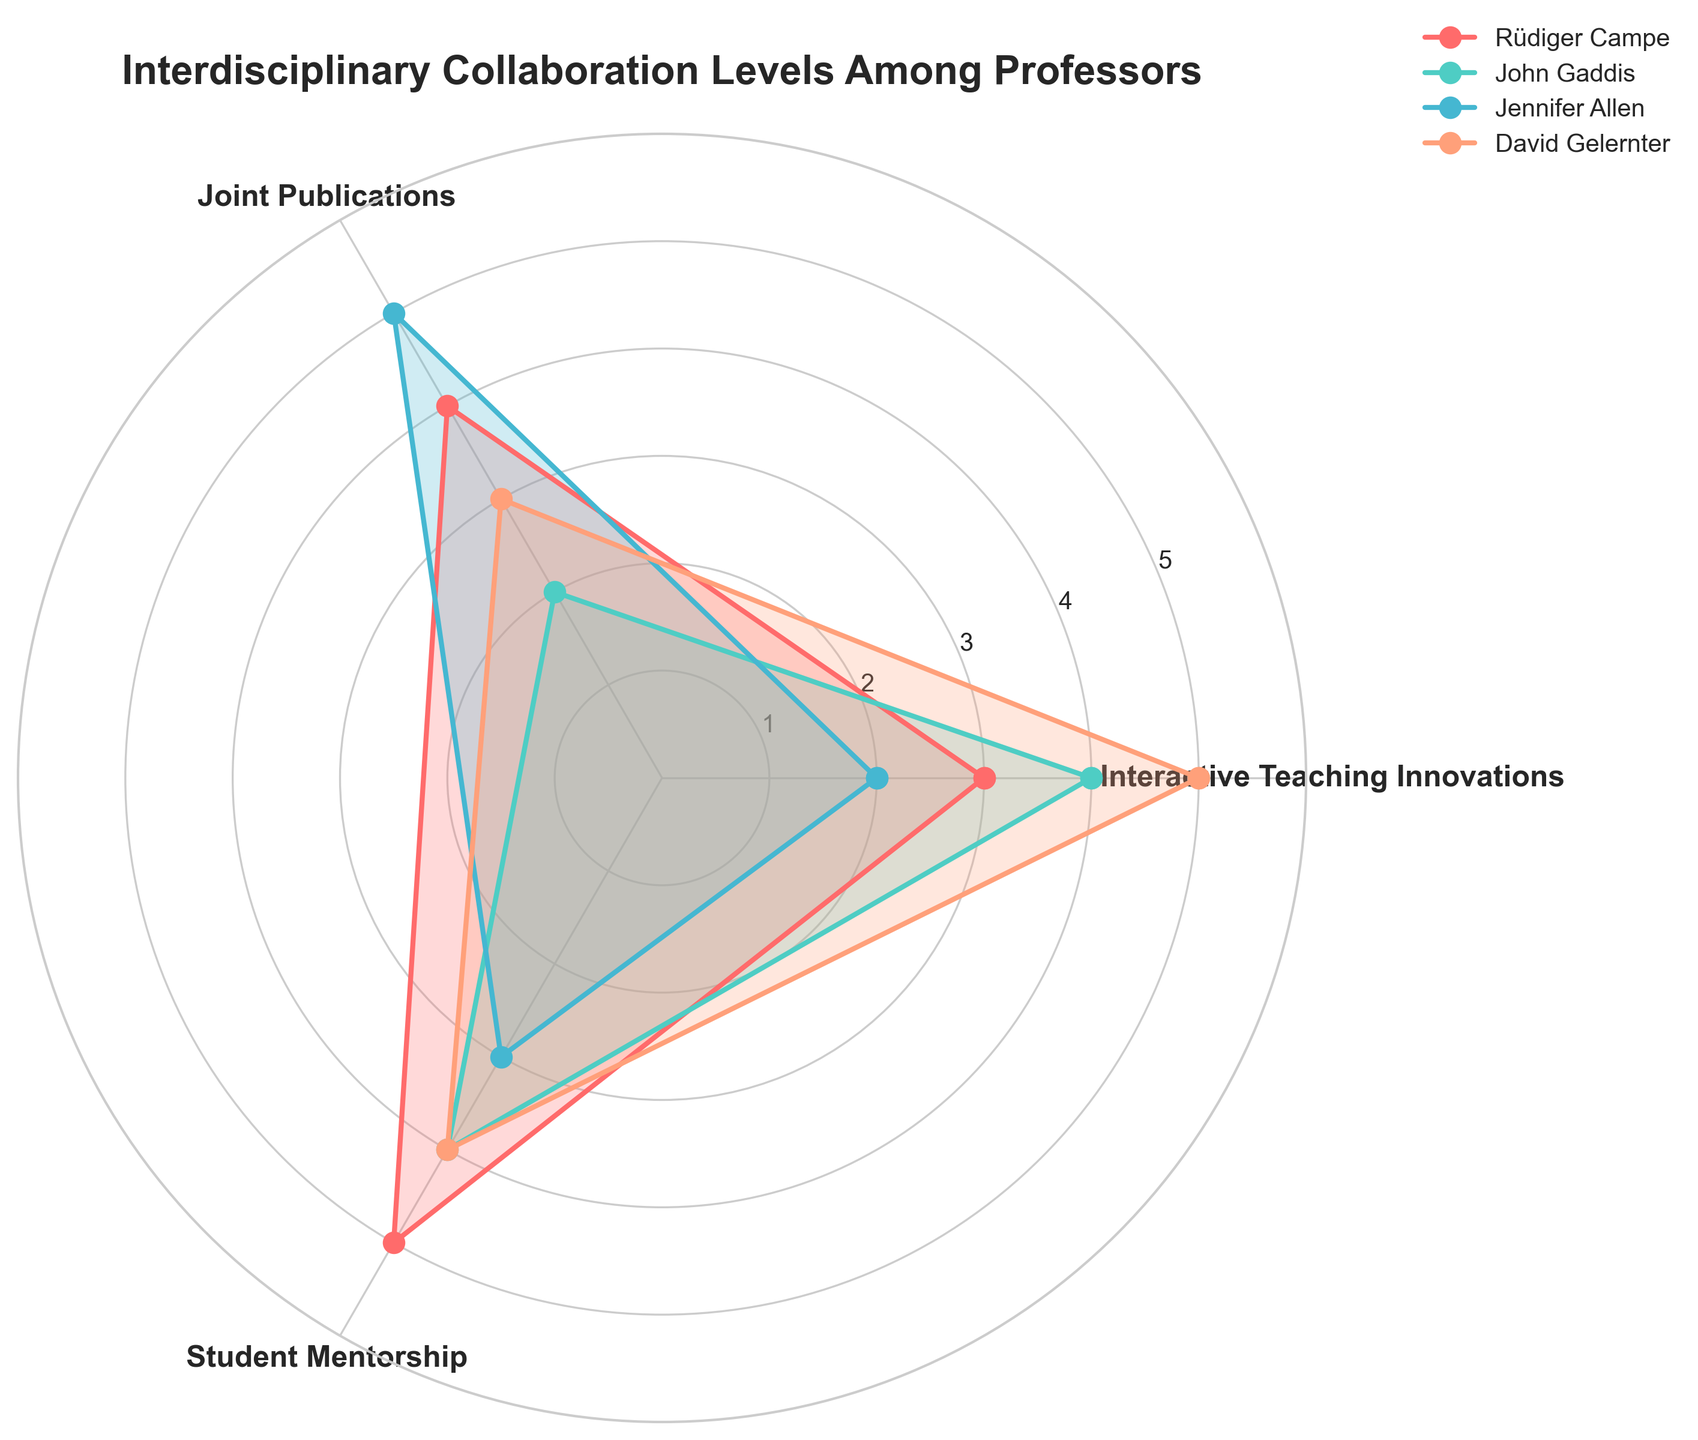What's the title of the radar chart? The title is displayed at the top of the radar chart. It reads "Interdisciplinary Collaboration Levels Among Professors".
Answer: Interdisciplinary Collaboration Levels Among Professors Which professor has the highest score in Interactive Teaching Innovations? By examining the radar chart, we see that David Gelernter's data line reaches the outermost circle (value = 5) in the segment labeled "Interactive Teaching Innovations".
Answer: David Gelernter How many categories are used in the radar chart? The radar chart divides the area into sections for each category. Counting these sections gives us three categories: Interactive Teaching Innovations, Joint Publications, and Student Mentorship.
Answer: 3 Which category does Rüdiger Campe have the highest score in and what is the score? By observing Rüdiger Campe's data line, we see it reaches the highest point (value = 5) in the Student Mentorship segment.
Answer: Student Mentorship, 5 What is the average score for Jennifer Allen across all categories? Summarize Jennifer Allen's scores (2 in Interactive Teaching Innovations, 5 in Joint Publications, and 3 in Student Mentorship), and then divide by the number of categories, which is 3. Thus, (2 + 5 + 3) / 3 = 10 / 3 ≈ 3.33.
Answer: 3.33 Compare the scores between John Gaddis and David Gelernter for Joint Publications. Who has the higher score and by how much? John Gaddis scores 2 in Joint Publications while David Gelernter scores 3. Subtracting these values gives us 3 - 2 = 1.
Answer: David Gelernter, by 1 What score does each professor have in the Student Mentorship category? Each professor's data line intersects the Student Mentorship segment at different points:
- Rüdiger Campe: 5
- John Gaddis: 4
- Jennifer Allen: 3
- David Gelernter: 4.
Answer: Rüdiger Campe: 5, John Gaddis: 4, Jennifer Allen: 3, David Gelernter: 4 If you sum the scores for Interactive Teaching Innovations across all professors, what is the total? Summarize the scores for Interactive Teaching Innovations category for all professors (3 for Rüdiger Campe, 4 for John Gaddis, 2 for Jennifer Allen, and 5 for David Gelernter). Thus, 3 + 4 + 2 + 5 = 14.
Answer: 14 